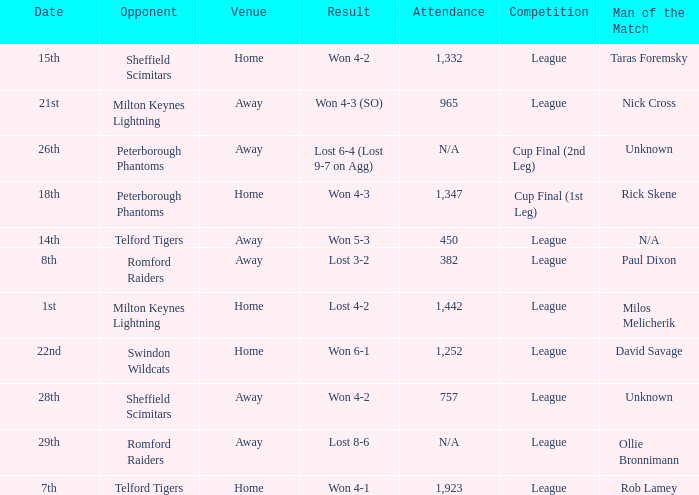Who was the Man of the Match when the opponent was Milton Keynes Lightning and the venue was Away? Nick Cross. 